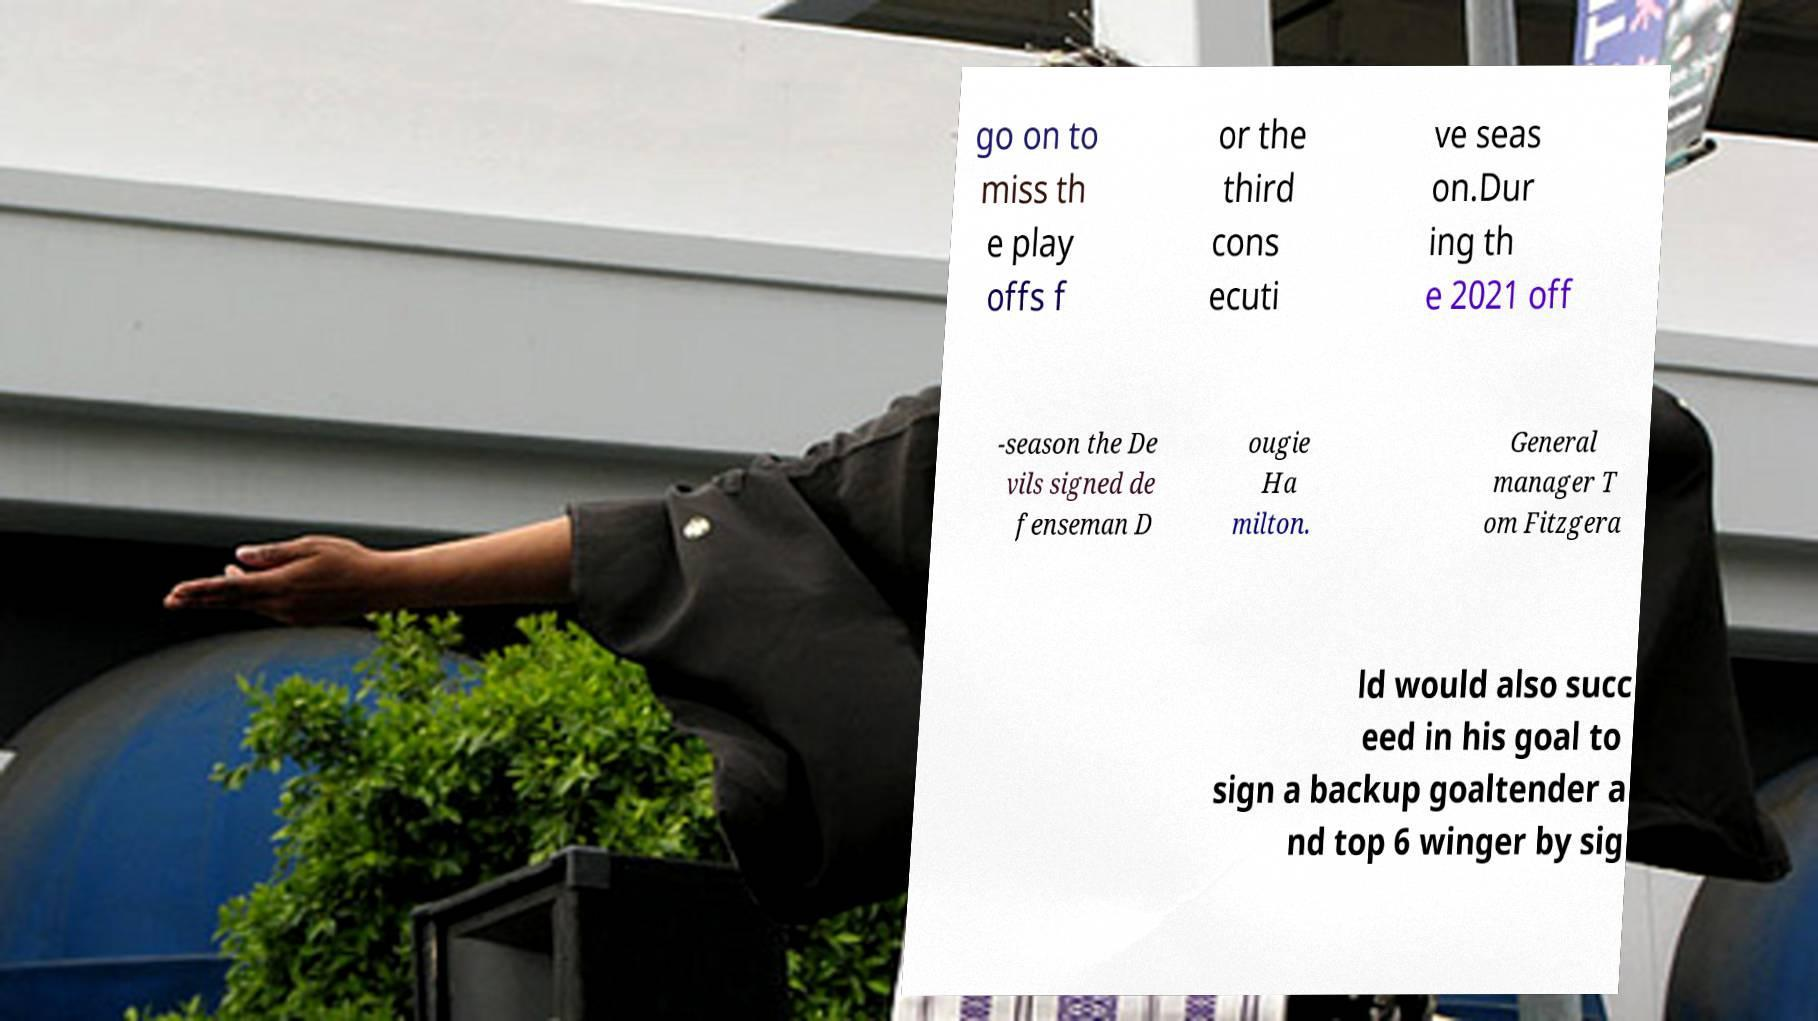Can you accurately transcribe the text from the provided image for me? go on to miss th e play offs f or the third cons ecuti ve seas on.Dur ing th e 2021 off -season the De vils signed de fenseman D ougie Ha milton. General manager T om Fitzgera ld would also succ eed in his goal to sign a backup goaltender a nd top 6 winger by sig 